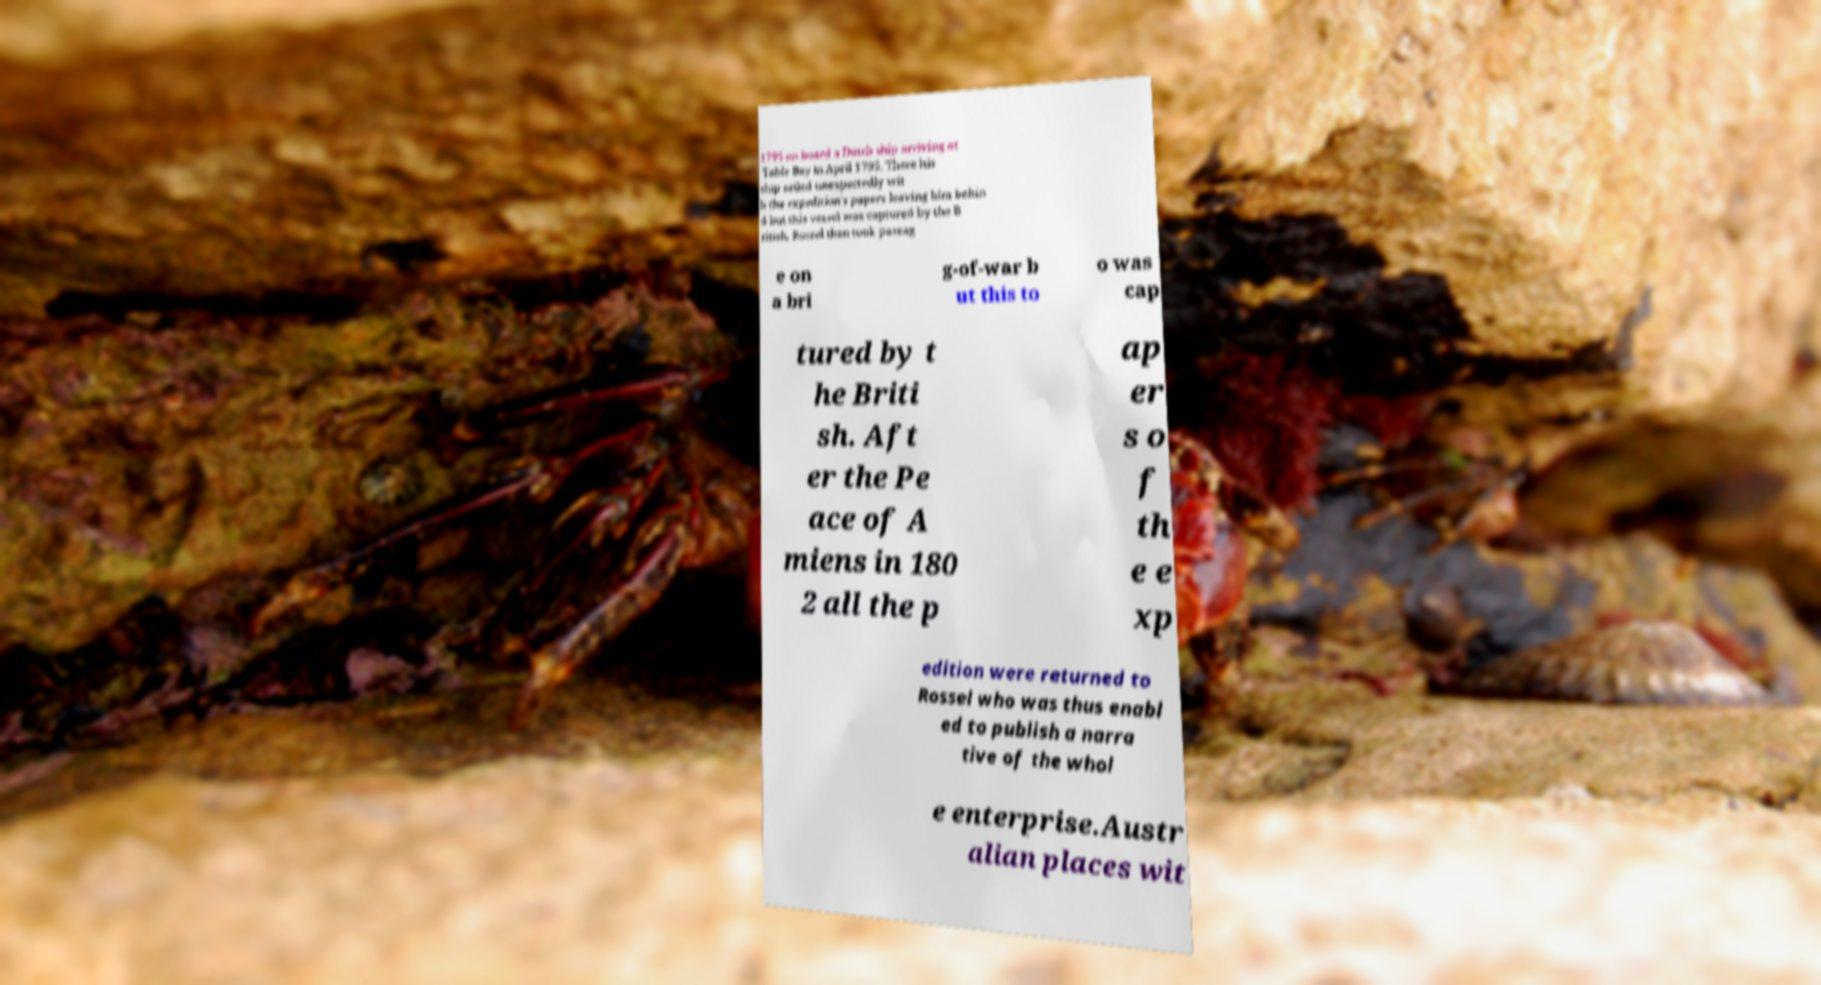Could you assist in decoding the text presented in this image and type it out clearly? 1795 on board a Dutch ship arriving at Table Bay in April 1795. There his ship sailed unexpectedly wit h the expedition's papers leaving him behin d but this vessel was captured by the B ritish. Rossel then took passag e on a bri g-of-war b ut this to o was cap tured by t he Briti sh. Aft er the Pe ace of A miens in 180 2 all the p ap er s o f th e e xp edition were returned to Rossel who was thus enabl ed to publish a narra tive of the whol e enterprise.Austr alian places wit 